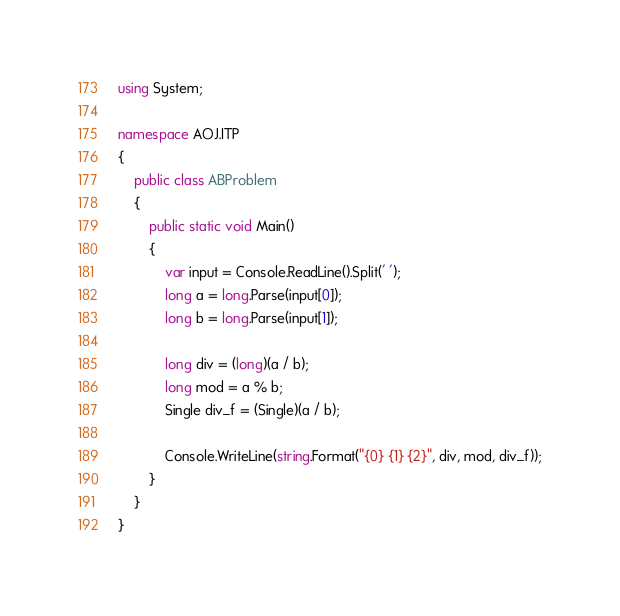Convert code to text. <code><loc_0><loc_0><loc_500><loc_500><_C#_>using System;

namespace AOJ.ITP
{
    public class ABProblem
    {
        public static void Main()
        {
            var input = Console.ReadLine().Split(' ');
            long a = long.Parse(input[0]);
            long b = long.Parse(input[1]);

            long div = (long)(a / b);
            long mod = a % b;
            Single div_f = (Single)(a / b);

            Console.WriteLine(string.Format("{0} {1} {2}", div, mod, div_f));
        }
    }
}</code> 